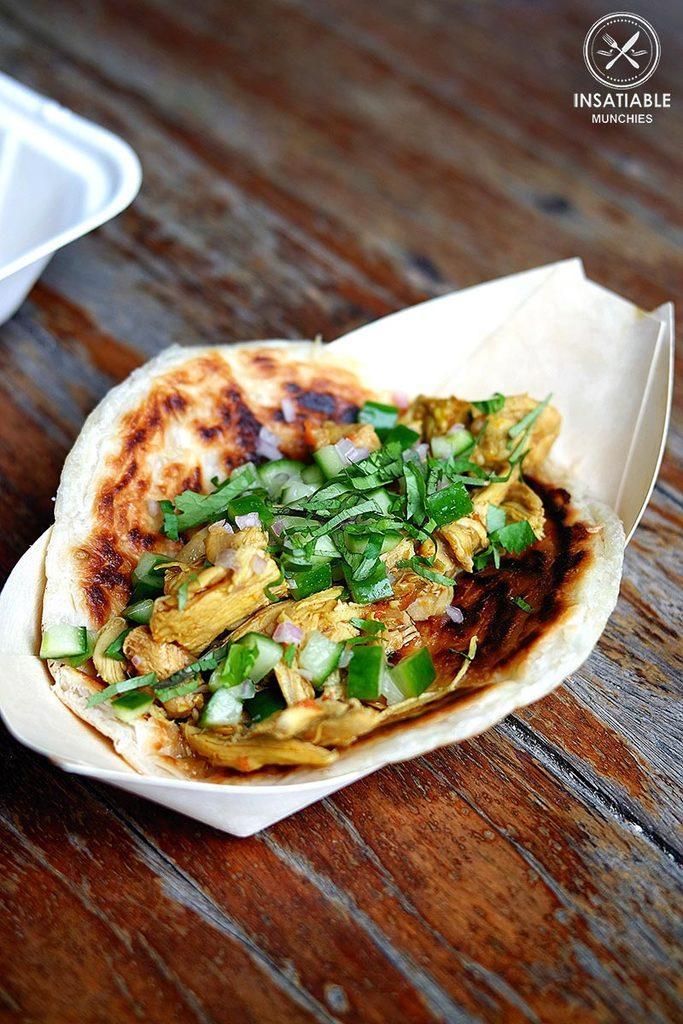How would you summarize this image in a sentence or two? This is a zoomed in picture. In the center there is a white color platter containing a food item and the platter is placed on the top of the wooden table. On the left corner there is a white color object placed on the table. At the top right corner there is a watermark on the image. 